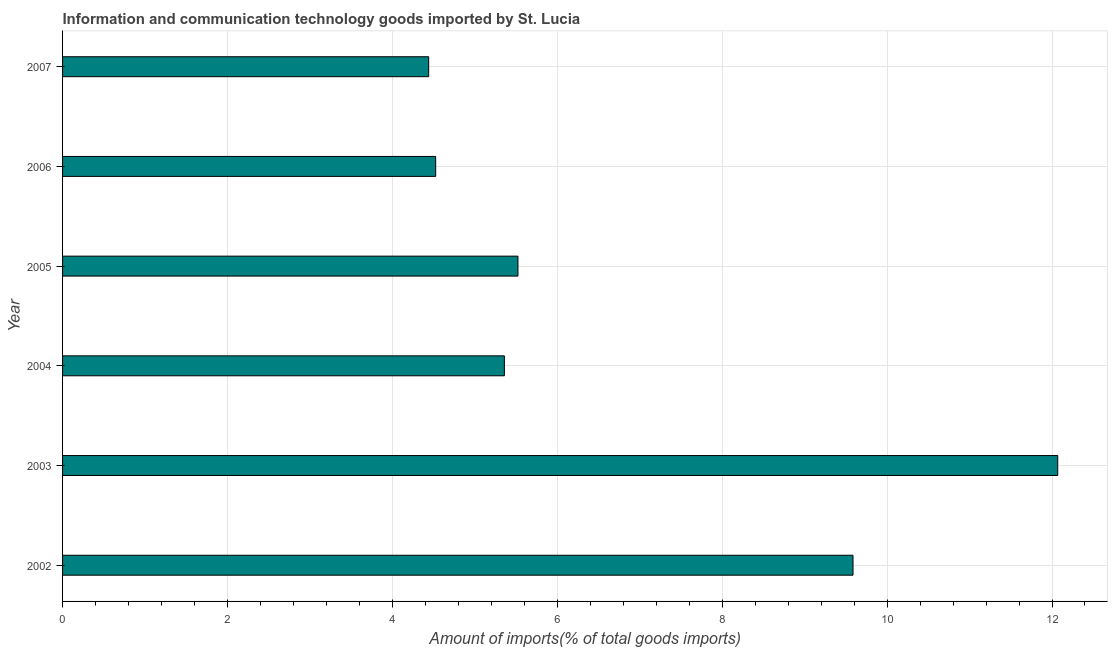What is the title of the graph?
Your answer should be very brief. Information and communication technology goods imported by St. Lucia. What is the label or title of the X-axis?
Provide a succinct answer. Amount of imports(% of total goods imports). What is the amount of ict goods imports in 2006?
Your answer should be compact. 4.53. Across all years, what is the maximum amount of ict goods imports?
Keep it short and to the point. 12.07. Across all years, what is the minimum amount of ict goods imports?
Make the answer very short. 4.44. What is the sum of the amount of ict goods imports?
Provide a short and direct response. 41.5. What is the difference between the amount of ict goods imports in 2003 and 2005?
Keep it short and to the point. 6.55. What is the average amount of ict goods imports per year?
Keep it short and to the point. 6.92. What is the median amount of ict goods imports?
Your answer should be very brief. 5.44. In how many years, is the amount of ict goods imports greater than 10.4 %?
Offer a very short reply. 1. Do a majority of the years between 2002 and 2007 (inclusive) have amount of ict goods imports greater than 9.6 %?
Provide a short and direct response. No. What is the ratio of the amount of ict goods imports in 2002 to that in 2006?
Keep it short and to the point. 2.12. Is the amount of ict goods imports in 2002 less than that in 2003?
Make the answer very short. Yes. What is the difference between the highest and the second highest amount of ict goods imports?
Give a very brief answer. 2.48. What is the difference between the highest and the lowest amount of ict goods imports?
Your answer should be very brief. 7.63. How many bars are there?
Give a very brief answer. 6. Are all the bars in the graph horizontal?
Your response must be concise. Yes. How many years are there in the graph?
Ensure brevity in your answer.  6. What is the difference between two consecutive major ticks on the X-axis?
Give a very brief answer. 2. What is the Amount of imports(% of total goods imports) in 2002?
Your answer should be compact. 9.59. What is the Amount of imports(% of total goods imports) in 2003?
Your answer should be very brief. 12.07. What is the Amount of imports(% of total goods imports) in 2004?
Offer a very short reply. 5.36. What is the Amount of imports(% of total goods imports) of 2005?
Make the answer very short. 5.52. What is the Amount of imports(% of total goods imports) of 2006?
Offer a terse response. 4.53. What is the Amount of imports(% of total goods imports) of 2007?
Make the answer very short. 4.44. What is the difference between the Amount of imports(% of total goods imports) in 2002 and 2003?
Make the answer very short. -2.48. What is the difference between the Amount of imports(% of total goods imports) in 2002 and 2004?
Provide a short and direct response. 4.23. What is the difference between the Amount of imports(% of total goods imports) in 2002 and 2005?
Provide a short and direct response. 4.06. What is the difference between the Amount of imports(% of total goods imports) in 2002 and 2006?
Offer a terse response. 5.06. What is the difference between the Amount of imports(% of total goods imports) in 2002 and 2007?
Give a very brief answer. 5.15. What is the difference between the Amount of imports(% of total goods imports) in 2003 and 2004?
Your answer should be very brief. 6.71. What is the difference between the Amount of imports(% of total goods imports) in 2003 and 2005?
Give a very brief answer. 6.55. What is the difference between the Amount of imports(% of total goods imports) in 2003 and 2006?
Ensure brevity in your answer.  7.54. What is the difference between the Amount of imports(% of total goods imports) in 2003 and 2007?
Keep it short and to the point. 7.63. What is the difference between the Amount of imports(% of total goods imports) in 2004 and 2005?
Your response must be concise. -0.16. What is the difference between the Amount of imports(% of total goods imports) in 2004 and 2006?
Make the answer very short. 0.83. What is the difference between the Amount of imports(% of total goods imports) in 2004 and 2007?
Provide a short and direct response. 0.92. What is the difference between the Amount of imports(% of total goods imports) in 2005 and 2007?
Provide a succinct answer. 1.08. What is the difference between the Amount of imports(% of total goods imports) in 2006 and 2007?
Keep it short and to the point. 0.08. What is the ratio of the Amount of imports(% of total goods imports) in 2002 to that in 2003?
Make the answer very short. 0.79. What is the ratio of the Amount of imports(% of total goods imports) in 2002 to that in 2004?
Ensure brevity in your answer.  1.79. What is the ratio of the Amount of imports(% of total goods imports) in 2002 to that in 2005?
Give a very brief answer. 1.74. What is the ratio of the Amount of imports(% of total goods imports) in 2002 to that in 2006?
Your response must be concise. 2.12. What is the ratio of the Amount of imports(% of total goods imports) in 2002 to that in 2007?
Your response must be concise. 2.16. What is the ratio of the Amount of imports(% of total goods imports) in 2003 to that in 2004?
Provide a short and direct response. 2.25. What is the ratio of the Amount of imports(% of total goods imports) in 2003 to that in 2005?
Provide a succinct answer. 2.19. What is the ratio of the Amount of imports(% of total goods imports) in 2003 to that in 2006?
Your response must be concise. 2.67. What is the ratio of the Amount of imports(% of total goods imports) in 2003 to that in 2007?
Ensure brevity in your answer.  2.72. What is the ratio of the Amount of imports(% of total goods imports) in 2004 to that in 2006?
Your answer should be very brief. 1.18. What is the ratio of the Amount of imports(% of total goods imports) in 2004 to that in 2007?
Give a very brief answer. 1.21. What is the ratio of the Amount of imports(% of total goods imports) in 2005 to that in 2006?
Give a very brief answer. 1.22. What is the ratio of the Amount of imports(% of total goods imports) in 2005 to that in 2007?
Provide a short and direct response. 1.24. 